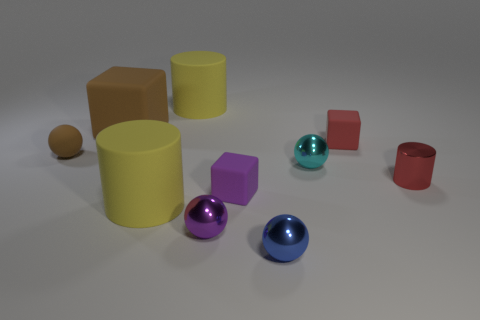There is a cylinder to the left of the yellow object behind the red rubber cube; what color is it?
Your answer should be compact. Yellow. How many objects are balls to the right of the big block or tiny rubber things?
Ensure brevity in your answer.  6. Do the cyan sphere and the yellow matte cylinder that is behind the red cylinder have the same size?
Provide a short and direct response. No. How many tiny objects are matte blocks or red things?
Your answer should be very brief. 3. What is the shape of the small purple shiny thing?
Your answer should be very brief. Sphere. There is a object that is the same color as the big cube; what size is it?
Ensure brevity in your answer.  Small. Is there a purple ball that has the same material as the blue thing?
Ensure brevity in your answer.  Yes. Are there more small rubber spheres than large cyan balls?
Provide a succinct answer. Yes. Does the red cylinder have the same material as the cyan object?
Ensure brevity in your answer.  Yes. How many shiny things are large cylinders or cylinders?
Your answer should be very brief. 1. 